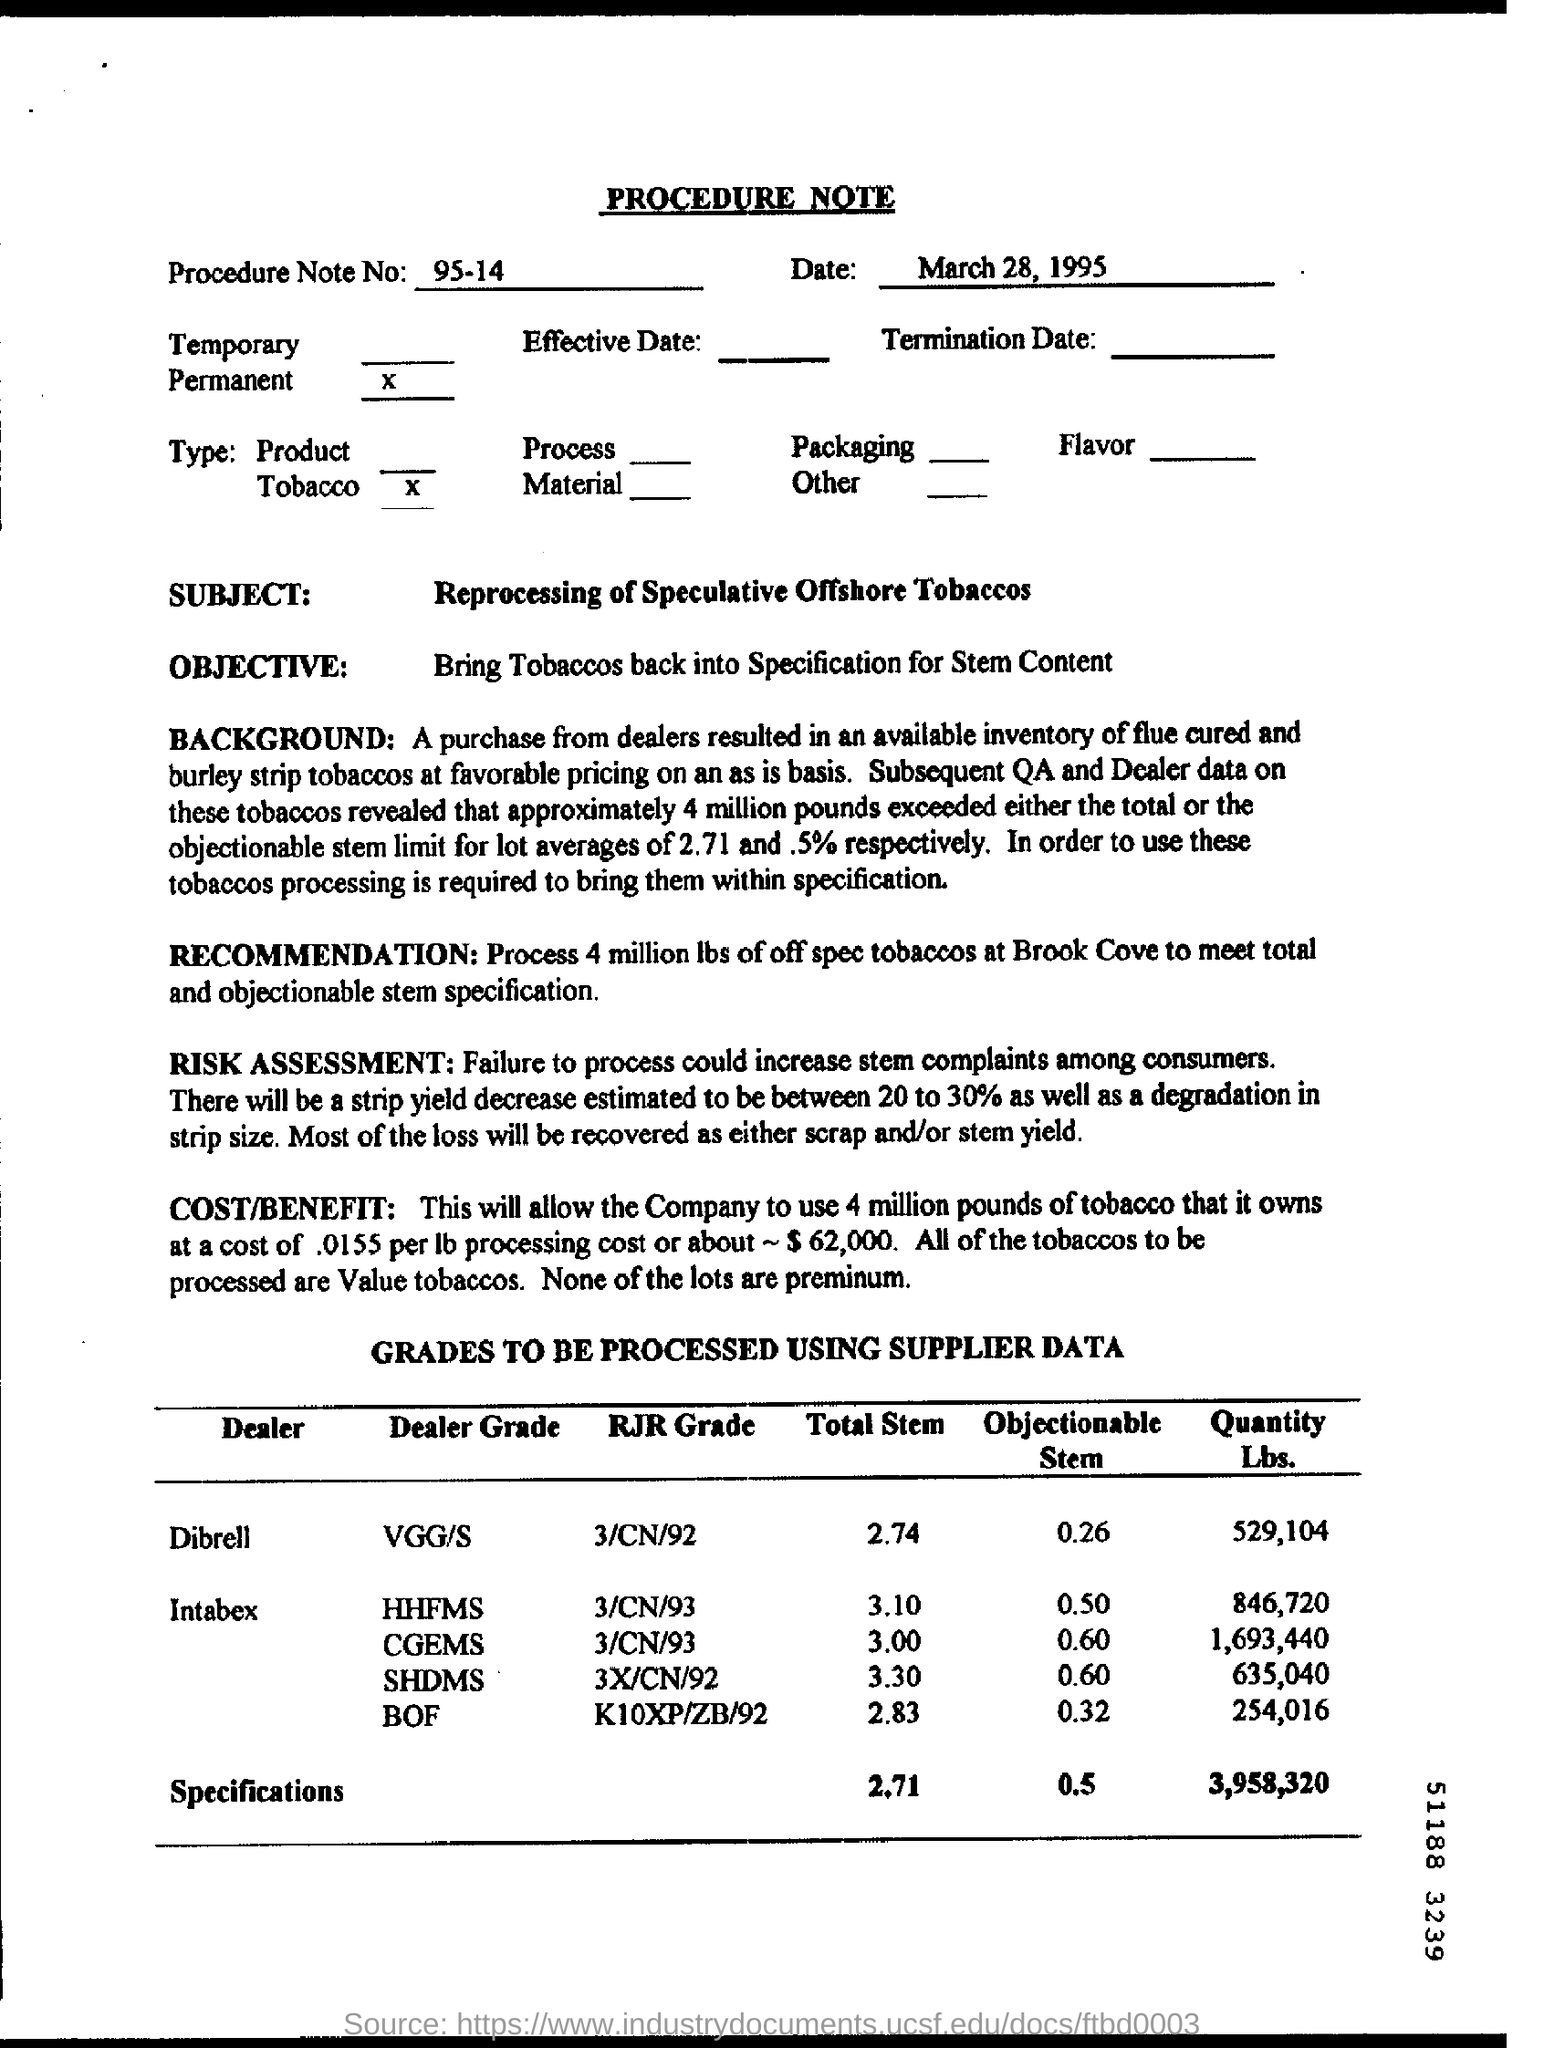What are some risks mentioned regarding the process? The document mentions that failing to process the tobacco correctly could increase complaints among consumers. There's also an estimated decrease in strip yield between 20 to 30% and a potential degradation in strip size, but most loss is expected to be recoverable as either scrap or stem yield. 